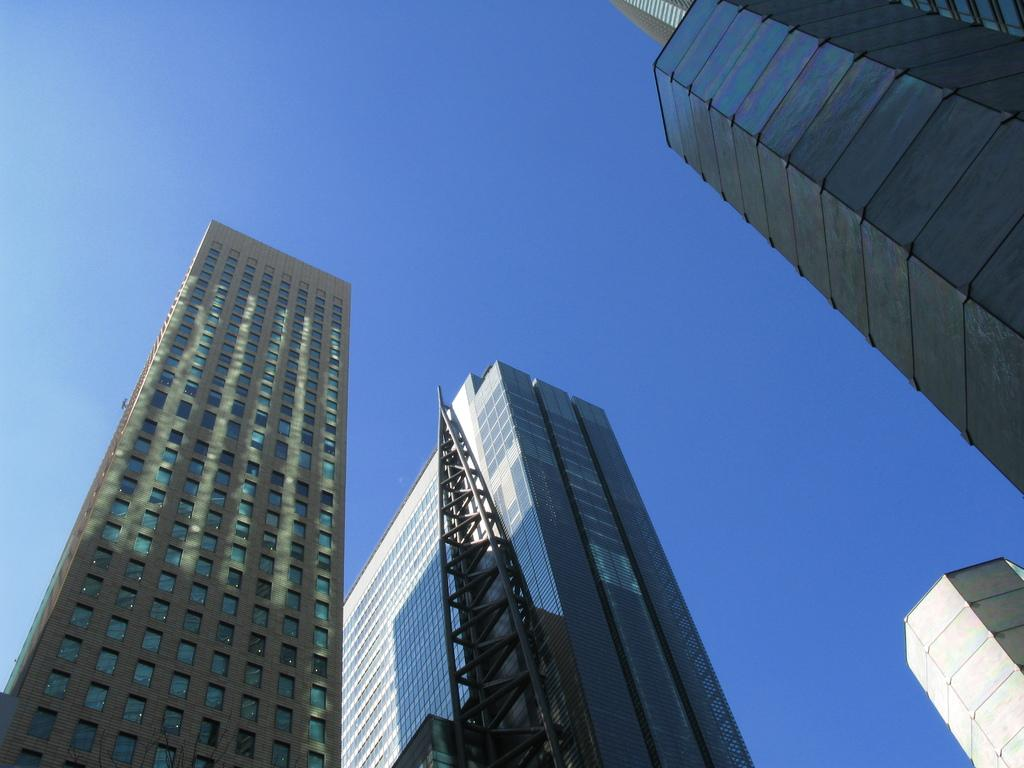What structures are present in the image? There are buildings in the image. What part of the natural environment can be seen in the image? The sky is visible in the background of the image. Where is the servant standing in the image? There is no servant present in the image. What type of field can be seen in the image? There is no field present in the image; it features buildings and the sky. 